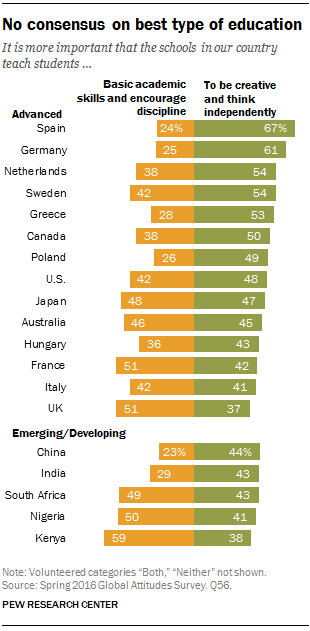Draw attention to some important aspects in this diagram. The orange bar in Greece has a value of 0.28. 